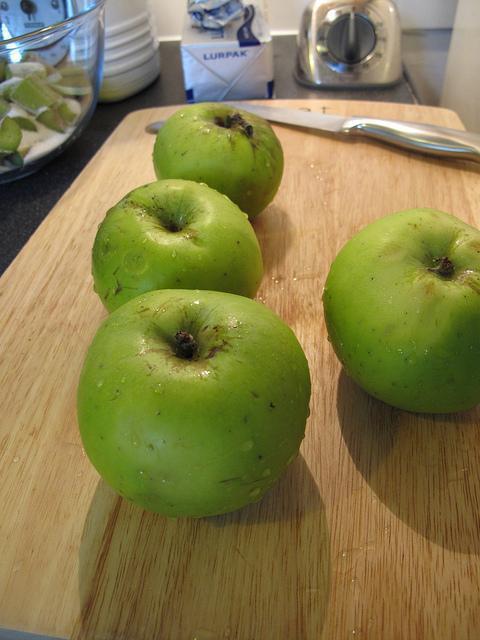How many apples are pictured?
Give a very brief answer. 4. How many apples can you see?
Give a very brief answer. 3. 